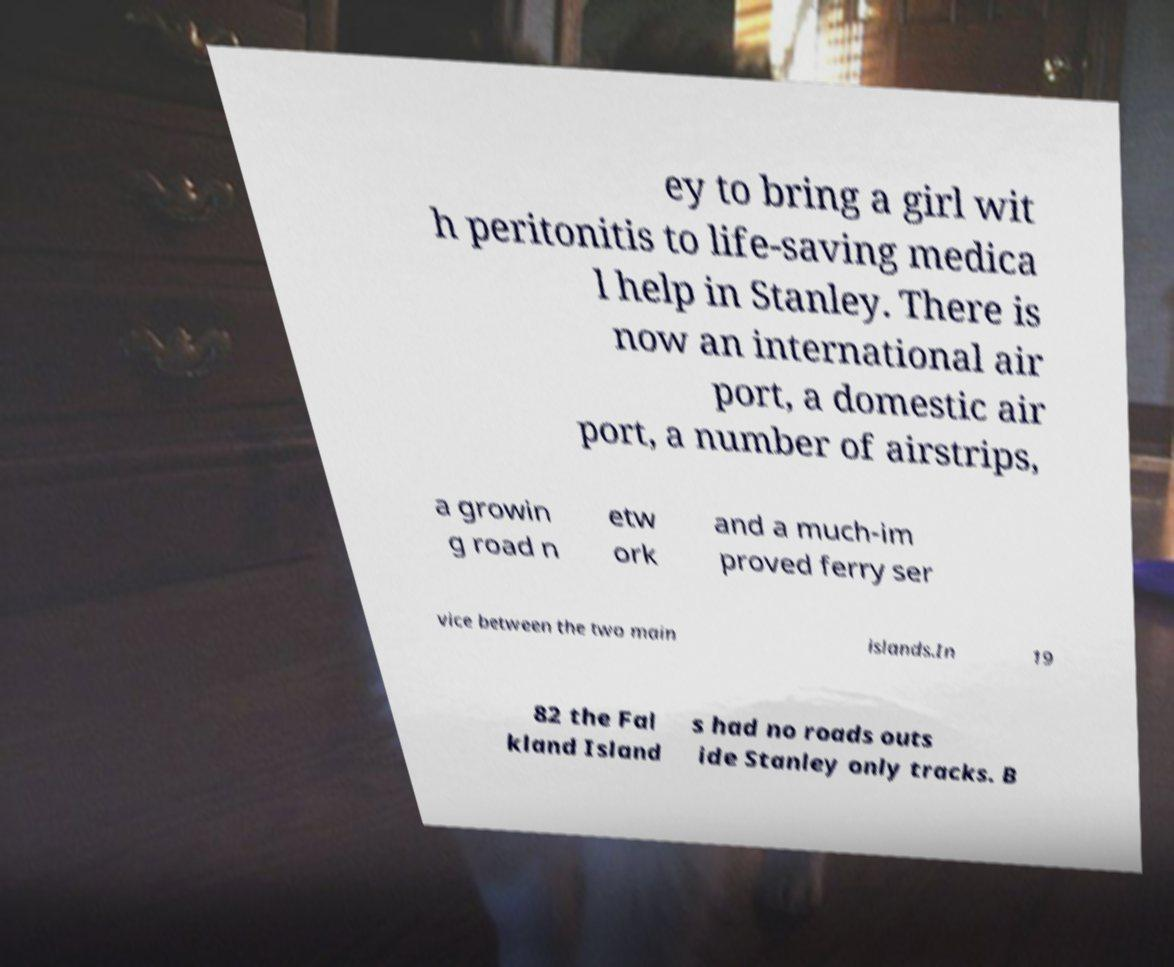I need the written content from this picture converted into text. Can you do that? ey to bring a girl wit h peritonitis to life-saving medica l help in Stanley. There is now an international air port, a domestic air port, a number of airstrips, a growin g road n etw ork and a much-im proved ferry ser vice between the two main islands.In 19 82 the Fal kland Island s had no roads outs ide Stanley only tracks. B 